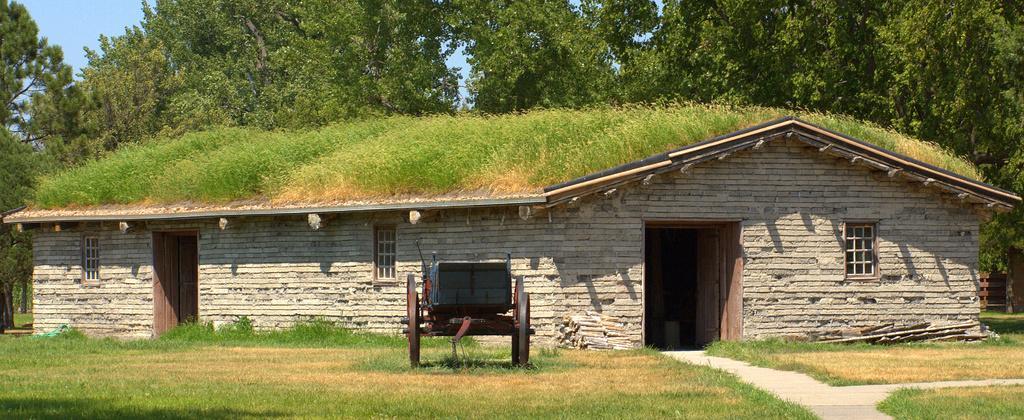Please provide a concise description of this image. There is one cart present on a grassy land as we can see at the bottom of this image. We can see planets on a house in the middle of this image. We can see trees at the top of this image and the sky is in the background. 